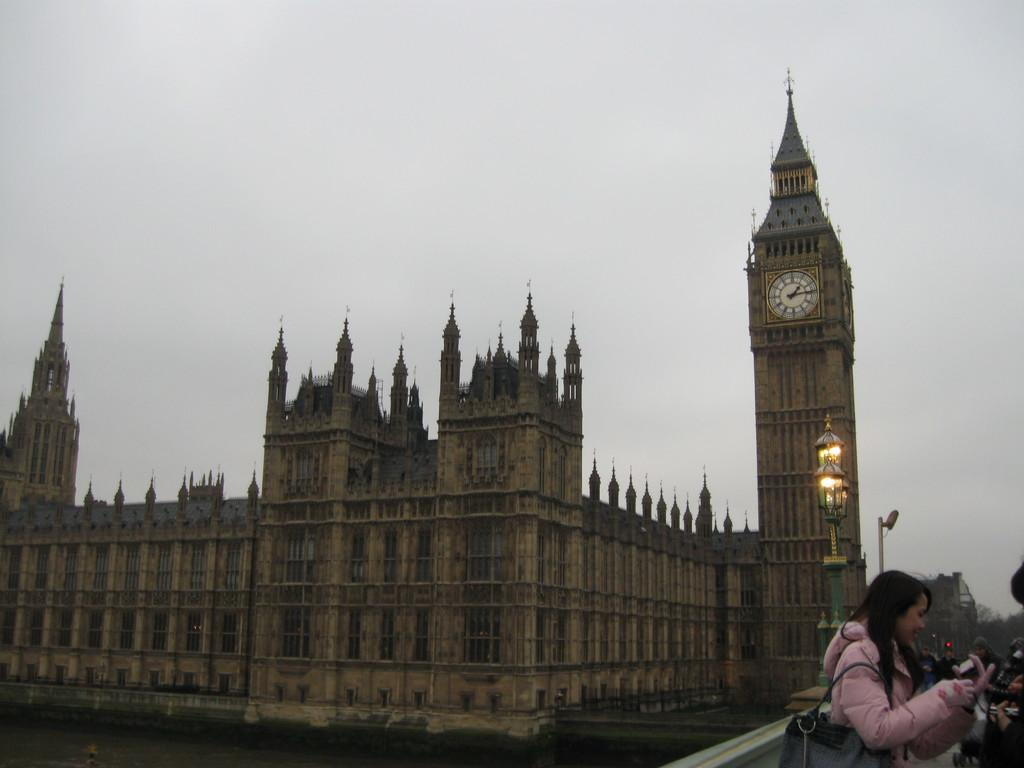What can be seen on the right side of the image? There are people on the right side of the image. What is the lady wearing in the image? The lady is wearing a bag in the image. Can you describe the pole in the image? There is a pole with lights in the image. What type of structure is present with a clock tower in the image? There is a building with a clock tower in the image. What is visible in the background of the image? The sky is visible in the background of the image. How many nails are used to hold the van in the image? There is no van present in the image, so the number of nails cannot be determined. What type of property is shown in the image? The image does not depict any specific property; it features a lady, people, a pole with lights, a building with a clock tower, and the sky. 